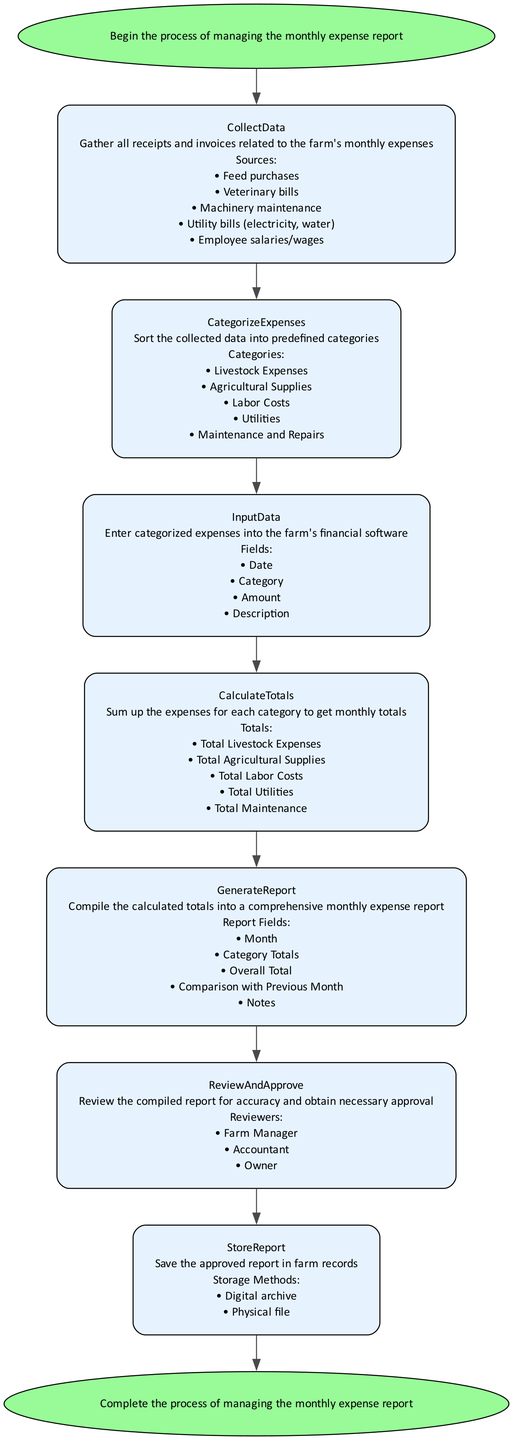What is the first step in the flowchart? The diagram starts with the "Start" node, which describes the beginning of the process for managing the monthly expense report.
Answer: Start How many categories are used in the "CategorizeExpenses" step? By examining the "CategorizeExpenses" node, we see that it lists five categories for sorting expenses.
Answer: Five What is the total number of nodes in the diagram? Counting all nodes listed in the diagram (including Start and End), we find a total of eight distinct nodes.
Answer: Eight Which software is mentioned for entering categorized expenses? The "InputData" node specifies "Farm Management Pro" as the example software for entering expenses.
Answer: Farm Management Pro Who are the reviewers listed in the "ReviewAndApprove" step? The "ReviewAndApprove" node includes three reviewers: the Farm Manager, Accountant, and Owner.
Answer: Farm Manager, Accountant, Owner What is the last step in the flowchart? The final node of the flowchart is labeled "End," indicating the completion of the expense report management process.
Answer: End What action occurs before generating the report? The "CalculateTotals" step must occur before generating the report, as it sums up expenses to compile totals necessary for the report.
Answer: CalculateTotals How many report fields are described in the "GenerateReport" step? The "GenerateReport" node outlines five fields that make up the comprehensive monthly expense report.
Answer: Five 